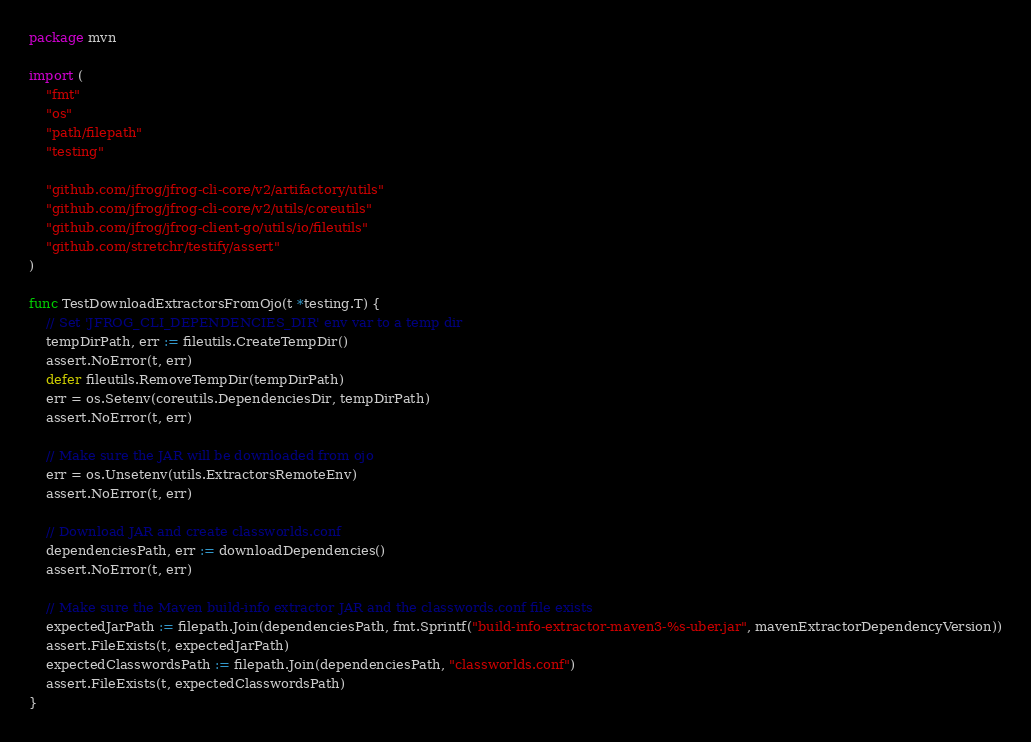Convert code to text. <code><loc_0><loc_0><loc_500><loc_500><_Go_>package mvn

import (
	"fmt"
	"os"
	"path/filepath"
	"testing"

	"github.com/jfrog/jfrog-cli-core/v2/artifactory/utils"
	"github.com/jfrog/jfrog-cli-core/v2/utils/coreutils"
	"github.com/jfrog/jfrog-client-go/utils/io/fileutils"
	"github.com/stretchr/testify/assert"
)

func TestDownloadExtractorsFromOjo(t *testing.T) {
	// Set 'JFROG_CLI_DEPENDENCIES_DIR' env var to a temp dir
	tempDirPath, err := fileutils.CreateTempDir()
	assert.NoError(t, err)
	defer fileutils.RemoveTempDir(tempDirPath)
	err = os.Setenv(coreutils.DependenciesDir, tempDirPath)
	assert.NoError(t, err)

	// Make sure the JAR will be downloaded from ojo
	err = os.Unsetenv(utils.ExtractorsRemoteEnv)
	assert.NoError(t, err)

	// Download JAR and create classworlds.conf
	dependenciesPath, err := downloadDependencies()
	assert.NoError(t, err)

	// Make sure the Maven build-info extractor JAR and the classwords.conf file exists
	expectedJarPath := filepath.Join(dependenciesPath, fmt.Sprintf("build-info-extractor-maven3-%s-uber.jar", mavenExtractorDependencyVersion))
	assert.FileExists(t, expectedJarPath)
	expectedClasswordsPath := filepath.Join(dependenciesPath, "classworlds.conf")
	assert.FileExists(t, expectedClasswordsPath)
}
</code> 